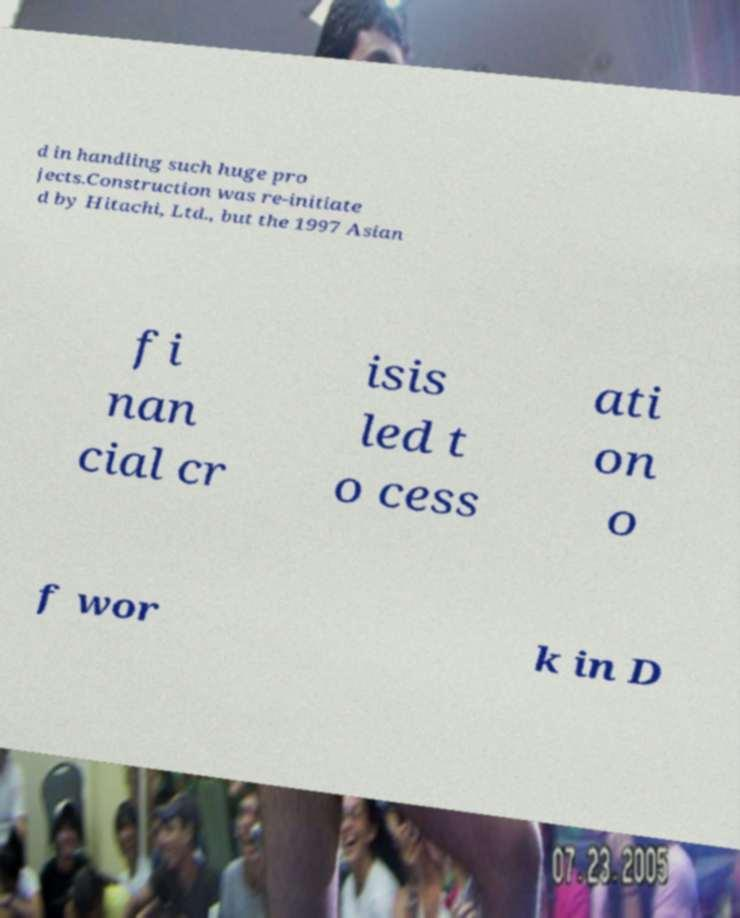There's text embedded in this image that I need extracted. Can you transcribe it verbatim? d in handling such huge pro jects.Construction was re-initiate d by Hitachi, Ltd., but the 1997 Asian fi nan cial cr isis led t o cess ati on o f wor k in D 